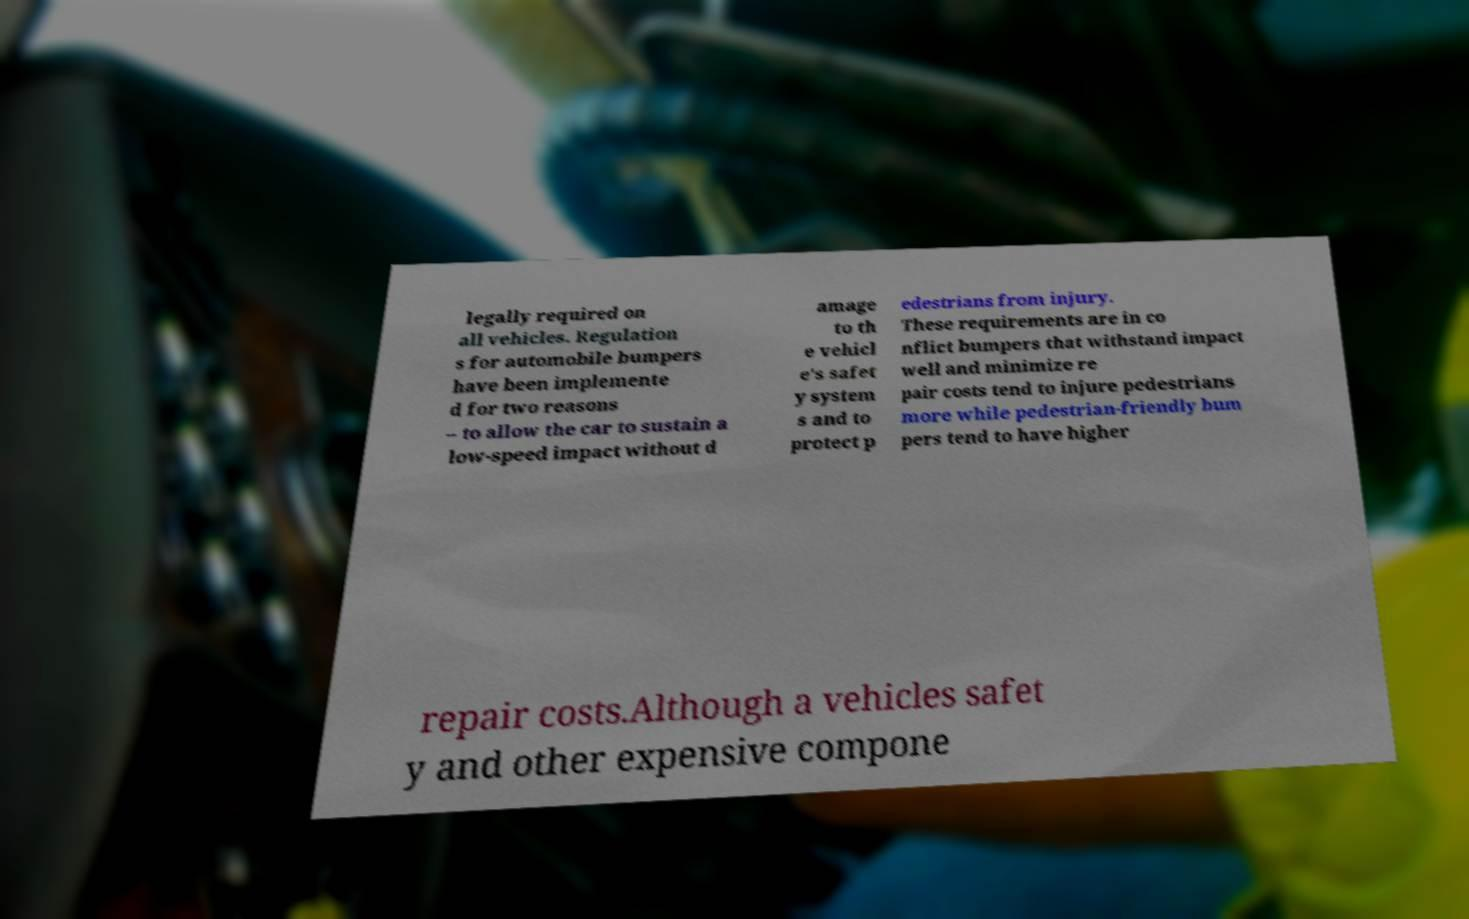Can you accurately transcribe the text from the provided image for me? legally required on all vehicles. Regulation s for automobile bumpers have been implemente d for two reasons – to allow the car to sustain a low-speed impact without d amage to th e vehicl e's safet y system s and to protect p edestrians from injury. These requirements are in co nflict bumpers that withstand impact well and minimize re pair costs tend to injure pedestrians more while pedestrian-friendly bum pers tend to have higher repair costs.Although a vehicles safet y and other expensive compone 